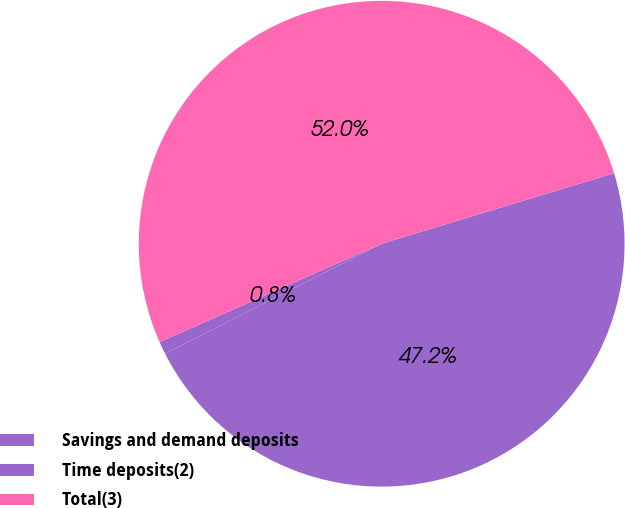Convert chart. <chart><loc_0><loc_0><loc_500><loc_500><pie_chart><fcel>Savings and demand deposits<fcel>Time deposits(2)<fcel>Total(3)<nl><fcel>47.22%<fcel>0.83%<fcel>51.95%<nl></chart> 